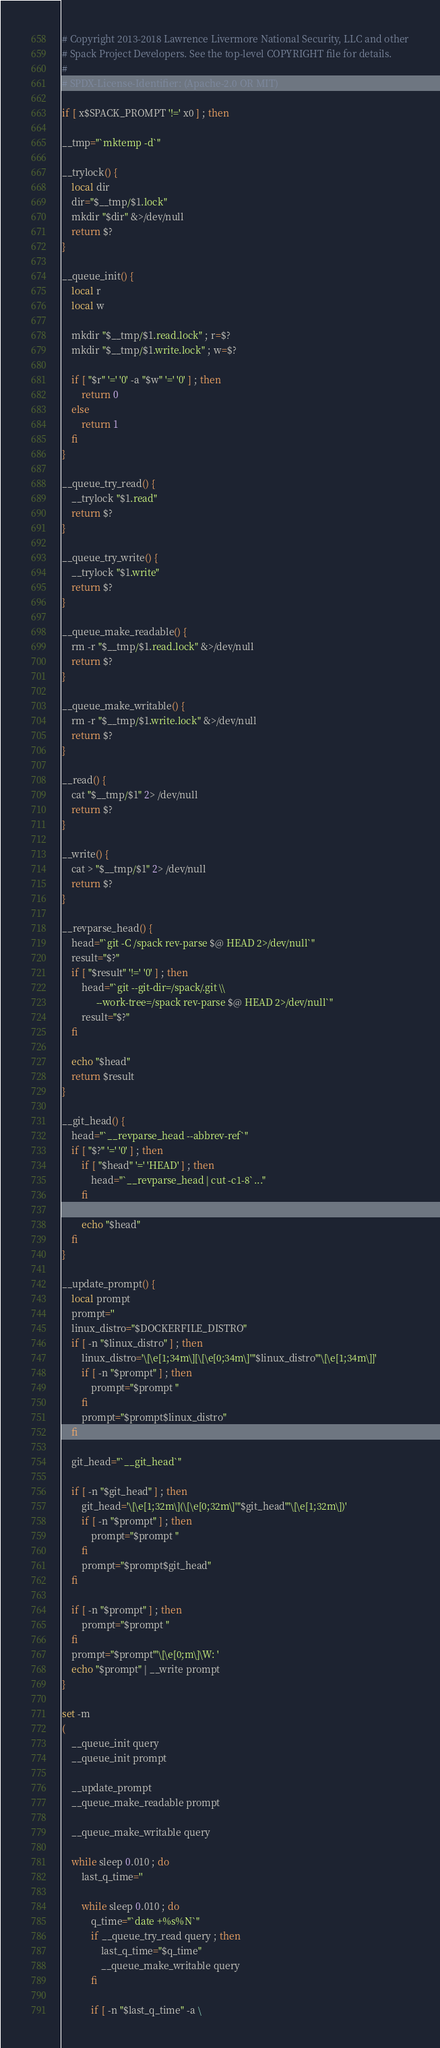<code> <loc_0><loc_0><loc_500><loc_500><_Bash_># Copyright 2013-2018 Lawrence Livermore National Security, LLC and other
# Spack Project Developers. See the top-level COPYRIGHT file for details.
#
# SPDX-License-Identifier: (Apache-2.0 OR MIT)

if [ x$SPACK_PROMPT '!=' x0 ] ; then

__tmp="`mktemp -d`"

__trylock() {
    local dir
    dir="$__tmp/$1.lock"
    mkdir "$dir" &>/dev/null
    return $?
}

__queue_init() {
    local r
    local w

    mkdir "$__tmp/$1.read.lock" ; r=$?
    mkdir "$__tmp/$1.write.lock" ; w=$?

    if [ "$r" '=' '0' -a "$w" '=' '0' ] ; then
        return 0
    else
        return 1
    fi
}

__queue_try_read() {
    __trylock "$1.read"
    return $?
}

__queue_try_write() {
    __trylock "$1.write"
    return $?
}

__queue_make_readable() {
    rm -r "$__tmp/$1.read.lock" &>/dev/null
    return $?
}

__queue_make_writable() {
    rm -r "$__tmp/$1.write.lock" &>/dev/null
    return $?
}

__read() {
    cat "$__tmp/$1" 2> /dev/null
    return $?
}

__write() {
    cat > "$__tmp/$1" 2> /dev/null
    return $?
}

__revparse_head() {
    head="`git -C /spack rev-parse $@ HEAD 2>/dev/null`"
    result="$?"
    if [ "$result" '!=' '0' ] ; then
        head="`git --git-dir=/spack/.git \\
              --work-tree=/spack rev-parse $@ HEAD 2>/dev/null`"
        result="$?"
    fi

    echo "$head"
    return $result
}

__git_head() {
    head="`__revparse_head --abbrev-ref`"
    if [ "$?" '=' '0' ] ; then
        if [ "$head" '=' 'HEAD' ] ; then
            head="`__revparse_head | cut -c1-8`..."
        fi

        echo "$head"
    fi
}

__update_prompt() {
    local prompt
    prompt=''
    linux_distro="$DOCKERFILE_DISTRO"
    if [ -n "$linux_distro" ] ; then
        linux_distro='\[\e[1;34m\][\[\e[0;34m\]'"$linux_distro"'\[\e[1;34m\]]'
        if [ -n "$prompt" ] ; then
            prompt="$prompt "
        fi
        prompt="$prompt$linux_distro"
    fi

    git_head="`__git_head`"

    if [ -n "$git_head" ] ; then
        git_head='\[\e[1;32m\](\[\e[0;32m\]'"$git_head"'\[\e[1;32m\])'
        if [ -n "$prompt" ] ; then
            prompt="$prompt "
        fi
        prompt="$prompt$git_head"
    fi

    if [ -n "$prompt" ] ; then
        prompt="$prompt "
    fi
    prompt="$prompt"'\[\e[0;m\]\W: '
    echo "$prompt" | __write prompt
}

set -m
(
    __queue_init query
    __queue_init prompt

    __update_prompt
    __queue_make_readable prompt

    __queue_make_writable query

    while sleep 0.010 ; do
        last_q_time=''

        while sleep 0.010 ; do
            q_time="`date +%s%N`"
            if __queue_try_read query ; then
                last_q_time="$q_time"
                __queue_make_writable query
            fi

            if [ -n "$last_q_time" -a \</code> 